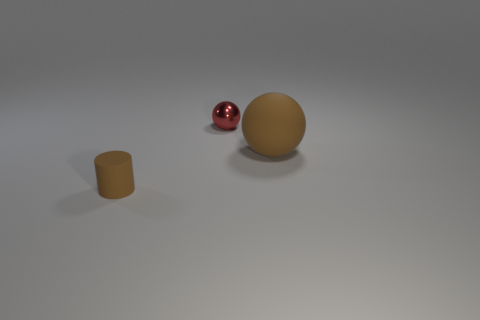There is a brown object that is behind the brown cylinder; how big is it?
Ensure brevity in your answer.  Large. The small metal thing has what shape?
Make the answer very short. Sphere. Is the size of the ball behind the big brown thing the same as the brown thing left of the brown matte ball?
Keep it short and to the point. Yes. There is a thing behind the rubber object behind the matte object in front of the large matte ball; what is its size?
Give a very brief answer. Small. What shape is the brown object in front of the brown rubber thing on the right side of the metal object behind the brown cylinder?
Give a very brief answer. Cylinder. There is a thing that is to the right of the tiny red thing; what shape is it?
Offer a very short reply. Sphere. Are the large brown object and the tiny thing that is right of the small matte cylinder made of the same material?
Make the answer very short. No. How many other objects are the same shape as the red object?
Give a very brief answer. 1. There is a large matte thing; is it the same color as the tiny thing that is to the right of the small brown matte cylinder?
Your answer should be very brief. No. Is there anything else that has the same material as the red sphere?
Offer a very short reply. No. 